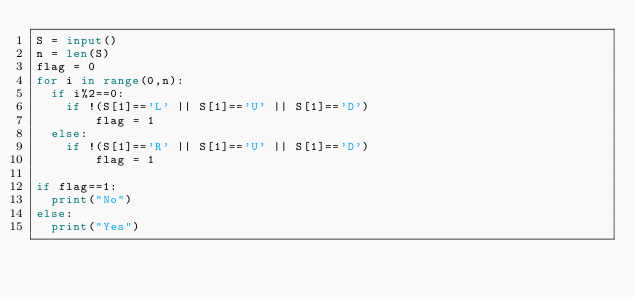Convert code to text. <code><loc_0><loc_0><loc_500><loc_500><_Python_>S = input()
n = len(S)
flag = 0
for i in range(0,n):
  if i%2==0:
  	if !(S[1]=='L' || S[1]=='U' || S[1]=='D')
    	flag = 1
  else:
    if !(S[1]=='R' || S[1]=='U' || S[1]=='D')
    	flag = 1
      
if flag==1:
  print("No")
else:
  print("Yes")</code> 